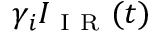Convert formula to latex. <formula><loc_0><loc_0><loc_500><loc_500>\gamma _ { i } I _ { I R } ( t )</formula> 